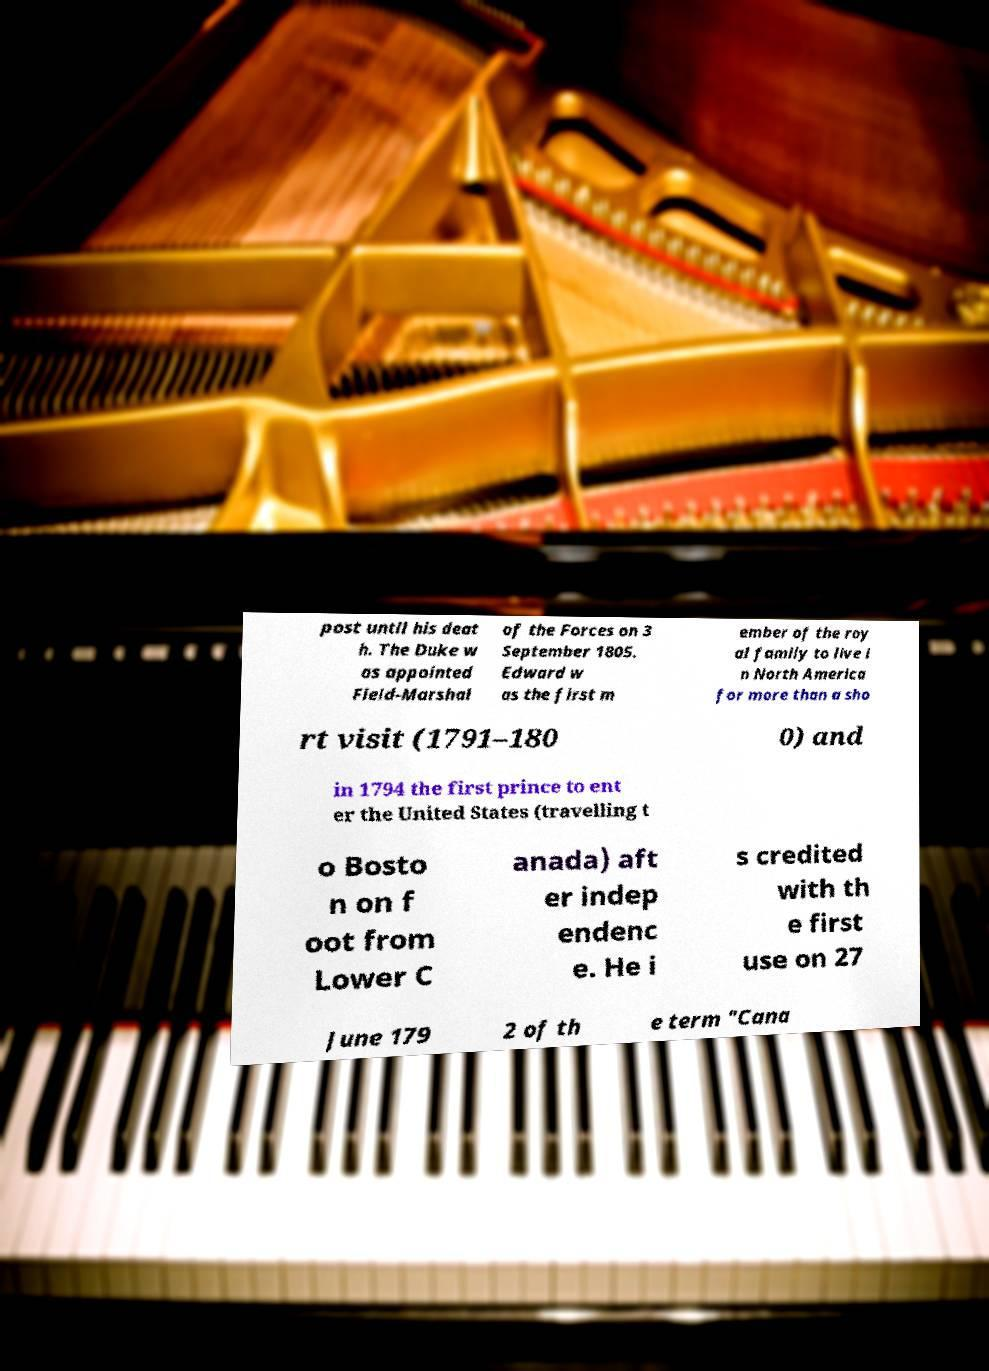Can you accurately transcribe the text from the provided image for me? post until his deat h. The Duke w as appointed Field-Marshal of the Forces on 3 September 1805. Edward w as the first m ember of the roy al family to live i n North America for more than a sho rt visit (1791–180 0) and in 1794 the first prince to ent er the United States (travelling t o Bosto n on f oot from Lower C anada) aft er indep endenc e. He i s credited with th e first use on 27 June 179 2 of th e term "Cana 